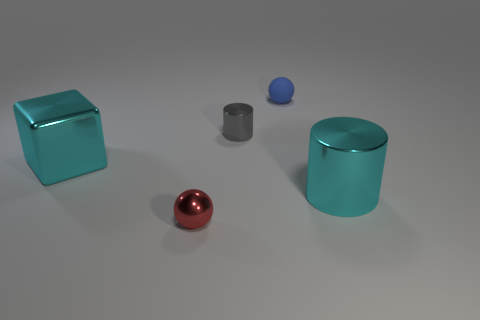Is there a blue ball made of the same material as the small red thing?
Provide a succinct answer. No. How many things are both to the left of the tiny matte sphere and in front of the big cyan block?
Offer a terse response. 1. What material is the tiny sphere that is behind the big metal cylinder?
Give a very brief answer. Rubber. What is the size of the cyan block that is made of the same material as the cyan cylinder?
Your answer should be compact. Large. Are there any tiny blue matte balls on the right side of the gray metallic cylinder?
Your answer should be very brief. Yes. There is another object that is the same shape as the small gray thing; what size is it?
Keep it short and to the point. Large. There is a block; does it have the same color as the big cylinder that is on the right side of the blue rubber object?
Your response must be concise. Yes. Do the big cube and the big cylinder have the same color?
Your response must be concise. Yes. Is the number of balls less than the number of small red shiny balls?
Make the answer very short. No. What number of other objects are there of the same color as the large block?
Keep it short and to the point. 1. 